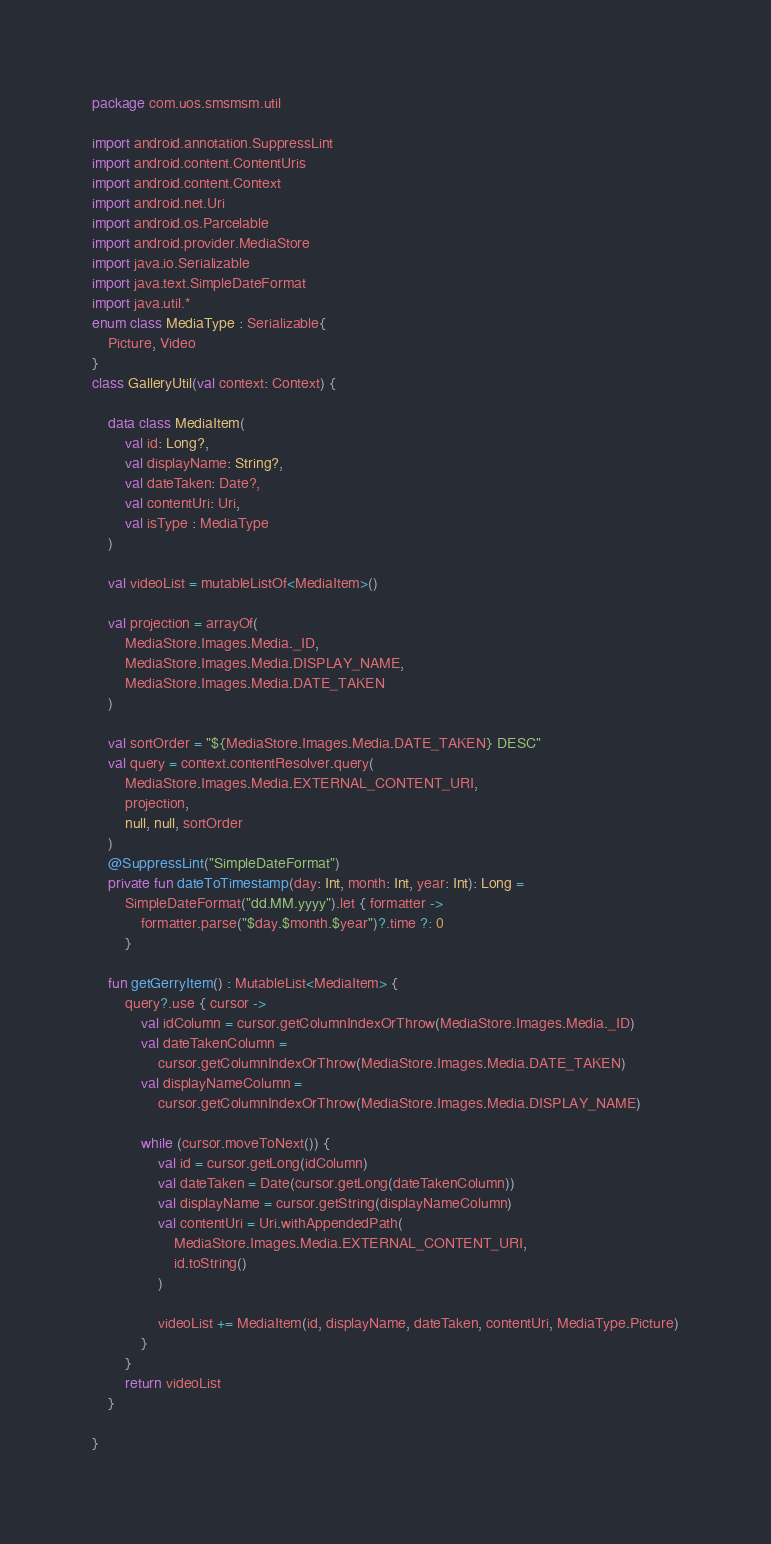<code> <loc_0><loc_0><loc_500><loc_500><_Kotlin_>package com.uos.smsmsm.util

import android.annotation.SuppressLint
import android.content.ContentUris
import android.content.Context
import android.net.Uri
import android.os.Parcelable
import android.provider.MediaStore
import java.io.Serializable
import java.text.SimpleDateFormat
import java.util.*
enum class MediaType : Serializable{
    Picture, Video
}
class GalleryUtil(val context: Context) {

    data class MediaItem(
        val id: Long?,
        val displayName: String?,
        val dateTaken: Date?,
        val contentUri: Uri,
        val isType : MediaType
    )

    val videoList = mutableListOf<MediaItem>()

    val projection = arrayOf(
        MediaStore.Images.Media._ID,
        MediaStore.Images.Media.DISPLAY_NAME,
        MediaStore.Images.Media.DATE_TAKEN
    )

    val sortOrder = "${MediaStore.Images.Media.DATE_TAKEN} DESC"
    val query = context.contentResolver.query(
        MediaStore.Images.Media.EXTERNAL_CONTENT_URI,
        projection,
        null, null, sortOrder
    )
    @SuppressLint("SimpleDateFormat")
    private fun dateToTimestamp(day: Int, month: Int, year: Int): Long =
        SimpleDateFormat("dd.MM.yyyy").let { formatter ->
            formatter.parse("$day.$month.$year")?.time ?: 0
        }

    fun getGerryItem() : MutableList<MediaItem> {
        query?.use { cursor ->
            val idColumn = cursor.getColumnIndexOrThrow(MediaStore.Images.Media._ID)
            val dateTakenColumn =
                cursor.getColumnIndexOrThrow(MediaStore.Images.Media.DATE_TAKEN)
            val displayNameColumn =
                cursor.getColumnIndexOrThrow(MediaStore.Images.Media.DISPLAY_NAME)

            while (cursor.moveToNext()) {
                val id = cursor.getLong(idColumn)
                val dateTaken = Date(cursor.getLong(dateTakenColumn))
                val displayName = cursor.getString(displayNameColumn)
                val contentUri = Uri.withAppendedPath(
                    MediaStore.Images.Media.EXTERNAL_CONTENT_URI,
                    id.toString()
                )

                videoList += MediaItem(id, displayName, dateTaken, contentUri, MediaType.Picture)
            }
        }
        return videoList
    }

}</code> 